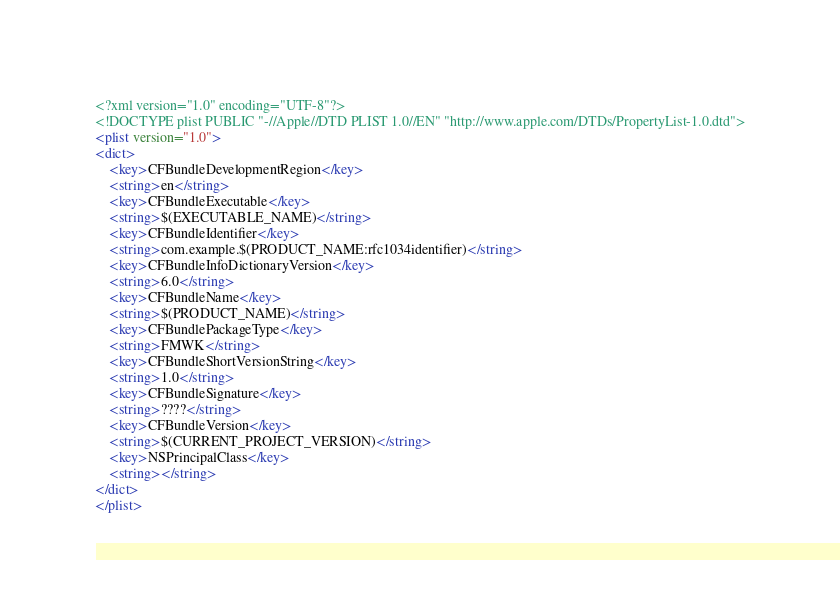Convert code to text. <code><loc_0><loc_0><loc_500><loc_500><_XML_><?xml version="1.0" encoding="UTF-8"?>
<!DOCTYPE plist PUBLIC "-//Apple//DTD PLIST 1.0//EN" "http://www.apple.com/DTDs/PropertyList-1.0.dtd">
<plist version="1.0">
<dict>
	<key>CFBundleDevelopmentRegion</key>
	<string>en</string>
	<key>CFBundleExecutable</key>
	<string>$(EXECUTABLE_NAME)</string>
	<key>CFBundleIdentifier</key>
	<string>com.example.$(PRODUCT_NAME:rfc1034identifier)</string>
	<key>CFBundleInfoDictionaryVersion</key>
	<string>6.0</string>
	<key>CFBundleName</key>
	<string>$(PRODUCT_NAME)</string>
	<key>CFBundlePackageType</key>
	<string>FMWK</string>
	<key>CFBundleShortVersionString</key>
	<string>1.0</string>
	<key>CFBundleSignature</key>
	<string>????</string>
	<key>CFBundleVersion</key>
	<string>$(CURRENT_PROJECT_VERSION)</string>
	<key>NSPrincipalClass</key>
	<string></string>
</dict>
</plist>
</code> 